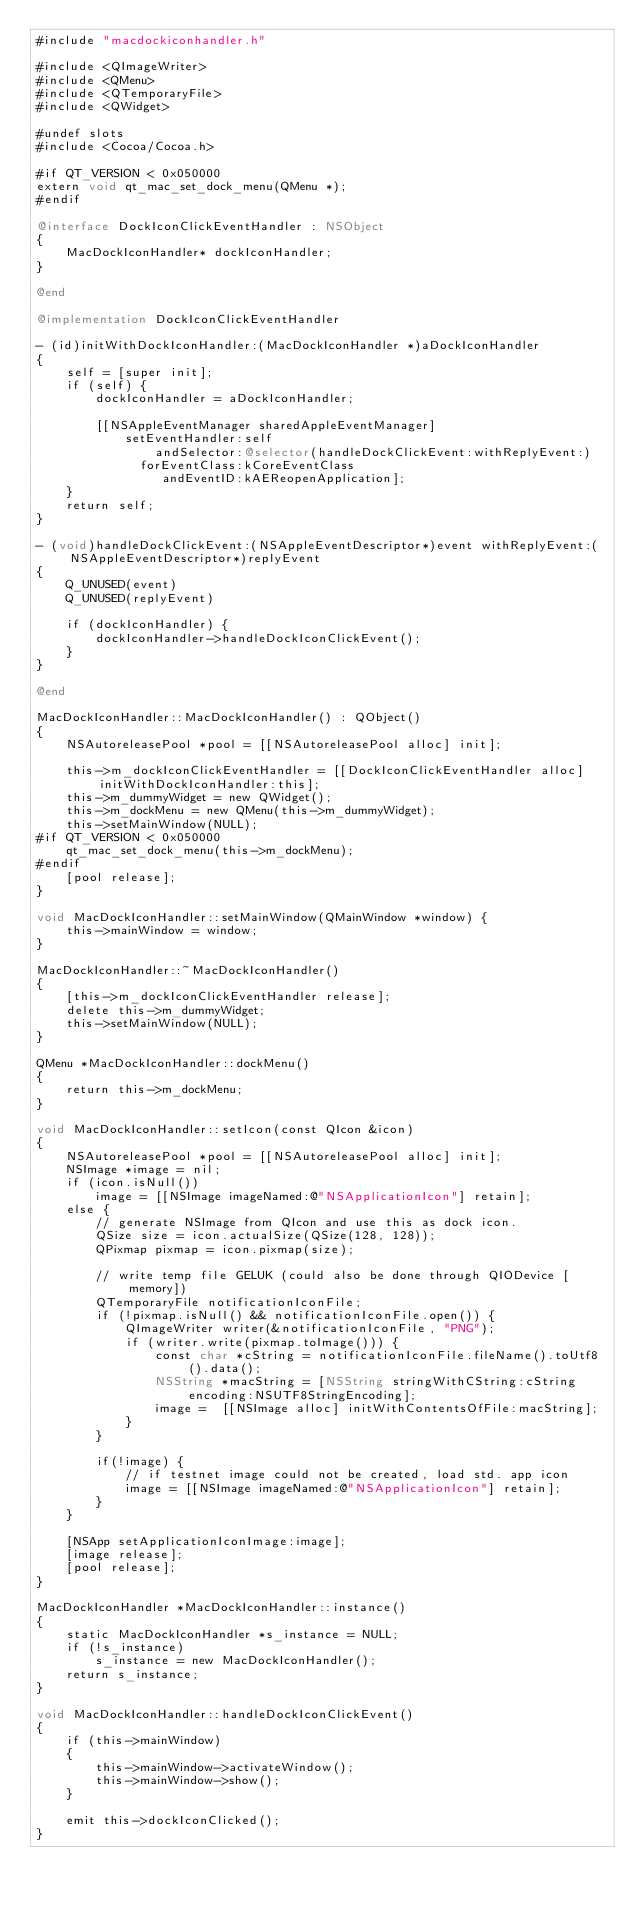Convert code to text. <code><loc_0><loc_0><loc_500><loc_500><_ObjectiveC_>#include "macdockiconhandler.h"

#include <QImageWriter>
#include <QMenu>
#include <QTemporaryFile>
#include <QWidget>

#undef slots
#include <Cocoa/Cocoa.h>

#if QT_VERSION < 0x050000
extern void qt_mac_set_dock_menu(QMenu *);
#endif

@interface DockIconClickEventHandler : NSObject
{
    MacDockIconHandler* dockIconHandler;
}

@end

@implementation DockIconClickEventHandler

- (id)initWithDockIconHandler:(MacDockIconHandler *)aDockIconHandler
{
    self = [super init];
    if (self) {
        dockIconHandler = aDockIconHandler;

        [[NSAppleEventManager sharedAppleEventManager]
            setEventHandler:self
                andSelector:@selector(handleDockClickEvent:withReplyEvent:)
              forEventClass:kCoreEventClass
                 andEventID:kAEReopenApplication];
    }
    return self;
}

- (void)handleDockClickEvent:(NSAppleEventDescriptor*)event withReplyEvent:(NSAppleEventDescriptor*)replyEvent
{
    Q_UNUSED(event)
    Q_UNUSED(replyEvent)

    if (dockIconHandler) {
        dockIconHandler->handleDockIconClickEvent();
    }
}

@end

MacDockIconHandler::MacDockIconHandler() : QObject()
{
    NSAutoreleasePool *pool = [[NSAutoreleasePool alloc] init];

    this->m_dockIconClickEventHandler = [[DockIconClickEventHandler alloc] initWithDockIconHandler:this];
    this->m_dummyWidget = new QWidget();
    this->m_dockMenu = new QMenu(this->m_dummyWidget);
    this->setMainWindow(NULL);
#if QT_VERSION < 0x050000
    qt_mac_set_dock_menu(this->m_dockMenu);
#endif
    [pool release];
}

void MacDockIconHandler::setMainWindow(QMainWindow *window) {
    this->mainWindow = window;
}

MacDockIconHandler::~MacDockIconHandler()
{
    [this->m_dockIconClickEventHandler release];
    delete this->m_dummyWidget;
    this->setMainWindow(NULL);
}

QMenu *MacDockIconHandler::dockMenu()
{
    return this->m_dockMenu;
}

void MacDockIconHandler::setIcon(const QIcon &icon)
{
    NSAutoreleasePool *pool = [[NSAutoreleasePool alloc] init];
    NSImage *image = nil;
    if (icon.isNull())
        image = [[NSImage imageNamed:@"NSApplicationIcon"] retain];
    else {
        // generate NSImage from QIcon and use this as dock icon.
        QSize size = icon.actualSize(QSize(128, 128));
        QPixmap pixmap = icon.pixmap(size);

        // write temp file GELUK (could also be done through QIODevice [memory])
        QTemporaryFile notificationIconFile;
        if (!pixmap.isNull() && notificationIconFile.open()) {
            QImageWriter writer(&notificationIconFile, "PNG");
            if (writer.write(pixmap.toImage())) {
                const char *cString = notificationIconFile.fileName().toUtf8().data();
                NSString *macString = [NSString stringWithCString:cString encoding:NSUTF8StringEncoding];
                image =  [[NSImage alloc] initWithContentsOfFile:macString];
            }
        }

        if(!image) {
            // if testnet image could not be created, load std. app icon
            image = [[NSImage imageNamed:@"NSApplicationIcon"] retain];
        }
    }

    [NSApp setApplicationIconImage:image];
    [image release];
    [pool release];
}

MacDockIconHandler *MacDockIconHandler::instance()
{
    static MacDockIconHandler *s_instance = NULL;
    if (!s_instance)
        s_instance = new MacDockIconHandler();
    return s_instance;
}

void MacDockIconHandler::handleDockIconClickEvent()
{
    if (this->mainWindow)
    {
        this->mainWindow->activateWindow();
        this->mainWindow->show();
    }

    emit this->dockIconClicked();
}
</code> 